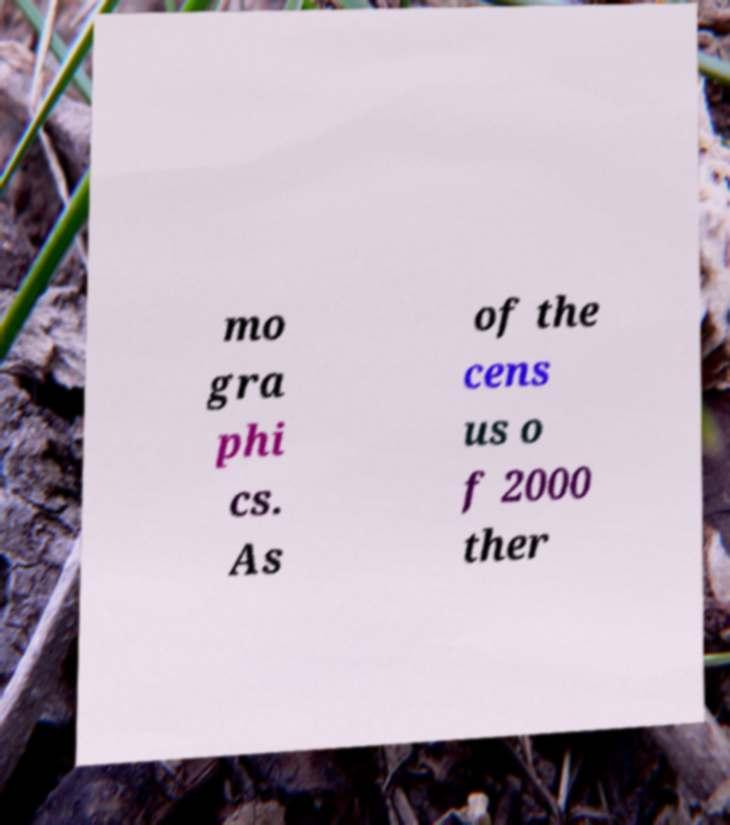Can you read and provide the text displayed in the image?This photo seems to have some interesting text. Can you extract and type it out for me? mo gra phi cs. As of the cens us o f 2000 ther 